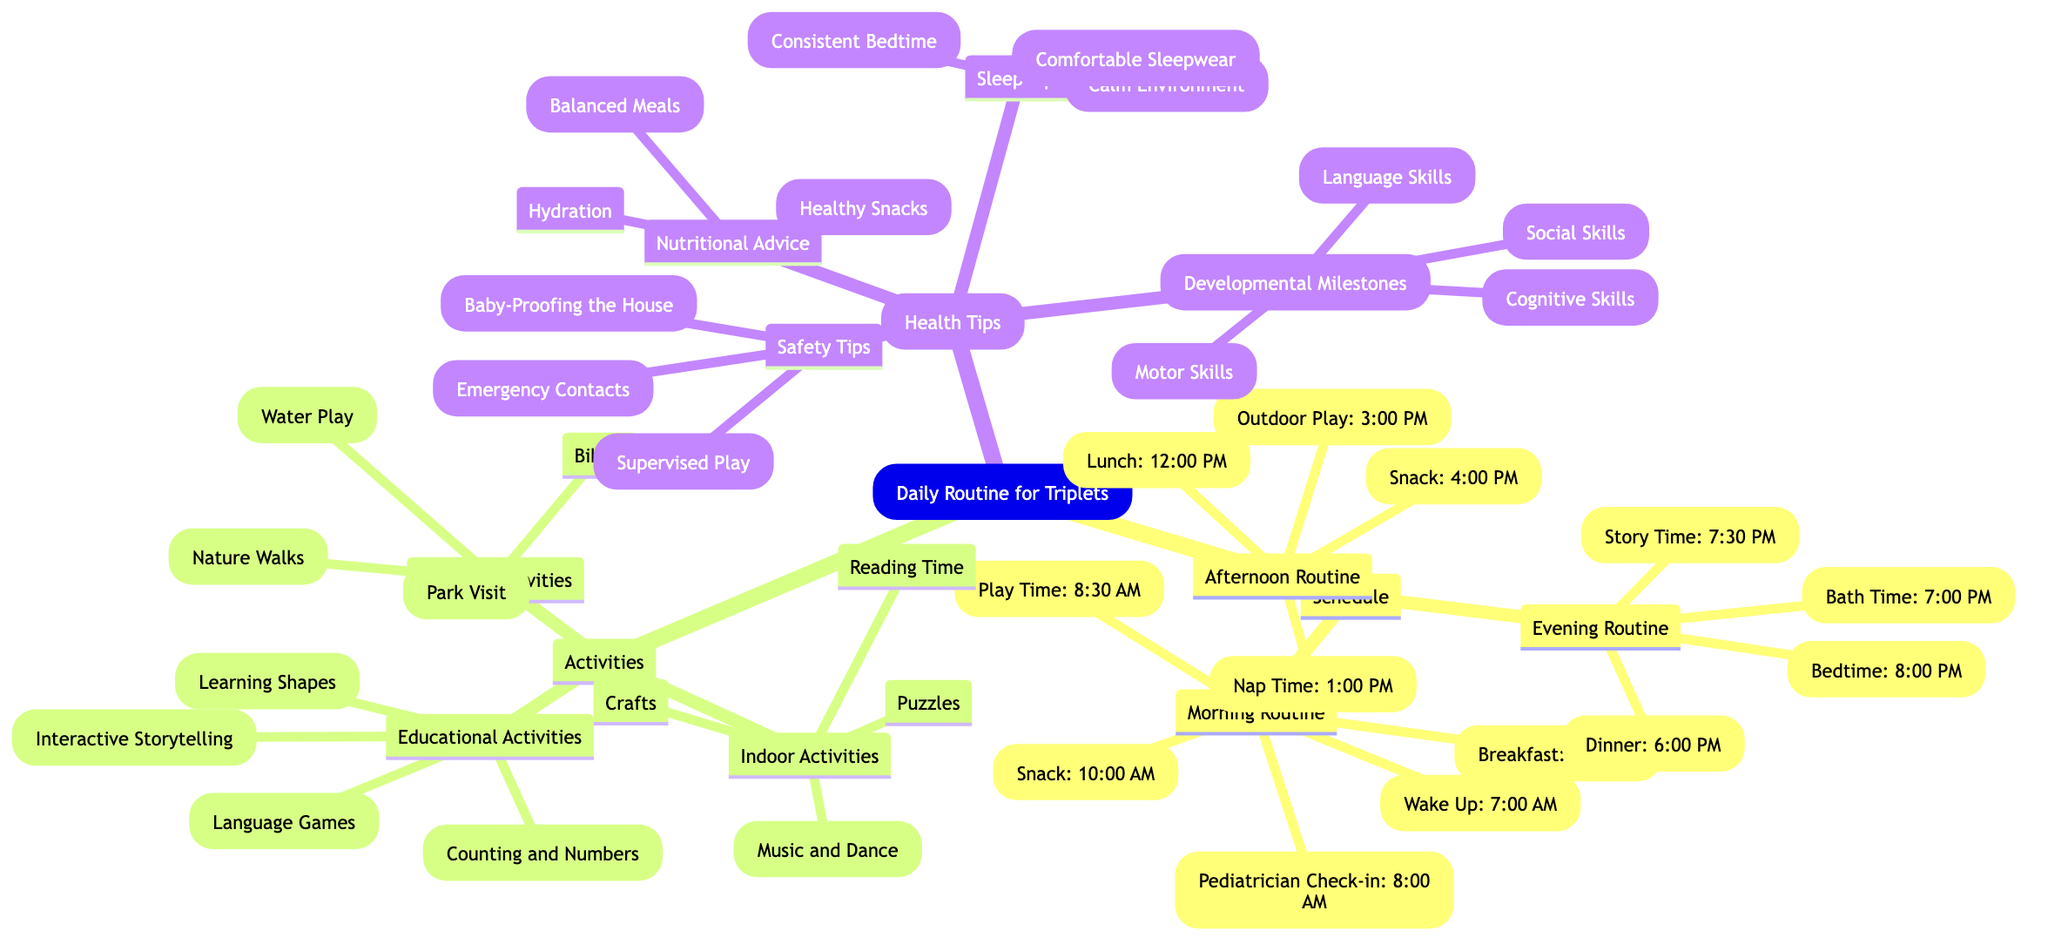What time does breakfast start? Breakfast is listed under the Morning Routine, which states it starts at 7:30 AM.
Answer: 7:30 AM How many snacks are scheduled throughout the day? There are two snacks listed: one in the morning at 10:00 AM and another in the afternoon at 4:00 PM, totaling two snacks.
Answer: 2 What are the outdoor activities mentioned? The diagram lists four outdoor activities: Park Visit, Nature Walks, Water Play, and Biking. These can be found under the Outdoor Activities section.
Answer: Park Visit, Nature Walks, Water Play, Biking What health tips focus on nutrition? Under Health Tips, Nutritional Advice includes Balanced Meals, Hydration, and Healthy Snacks. Collectively, these tips emphasize nutrition.
Answer: Balanced Meals, Hydration, Healthy Snacks What is the bedtime for the triplets? The Bedtime is listed as 8:00 PM under the Evening Routine, directly answering the question of when they should go to sleep.
Answer: 8:00 PM Which activity category does "Learning Shapes" fall under? "Learning Shapes" is specifically listed in the Educational Activities section, confirming this category for the activity.
Answer: Educational Activities What is the first activity after waking up? The first activity listed after Wake Up in the Morning Routine is Breakfast at 7:30 AM.
Answer: Breakfast Name a safety tip included in the health tips. One of the safety tips is Baby-Proofing the House, which can be found under the Safety Tips section in Health Tips.
Answer: Baby-Proofing the House How many activities are focused on motor skills? There is one activity listed under Developmental Milestones, specifically Motor Skills. Thus, the answer reflects this count.
Answer: 1 